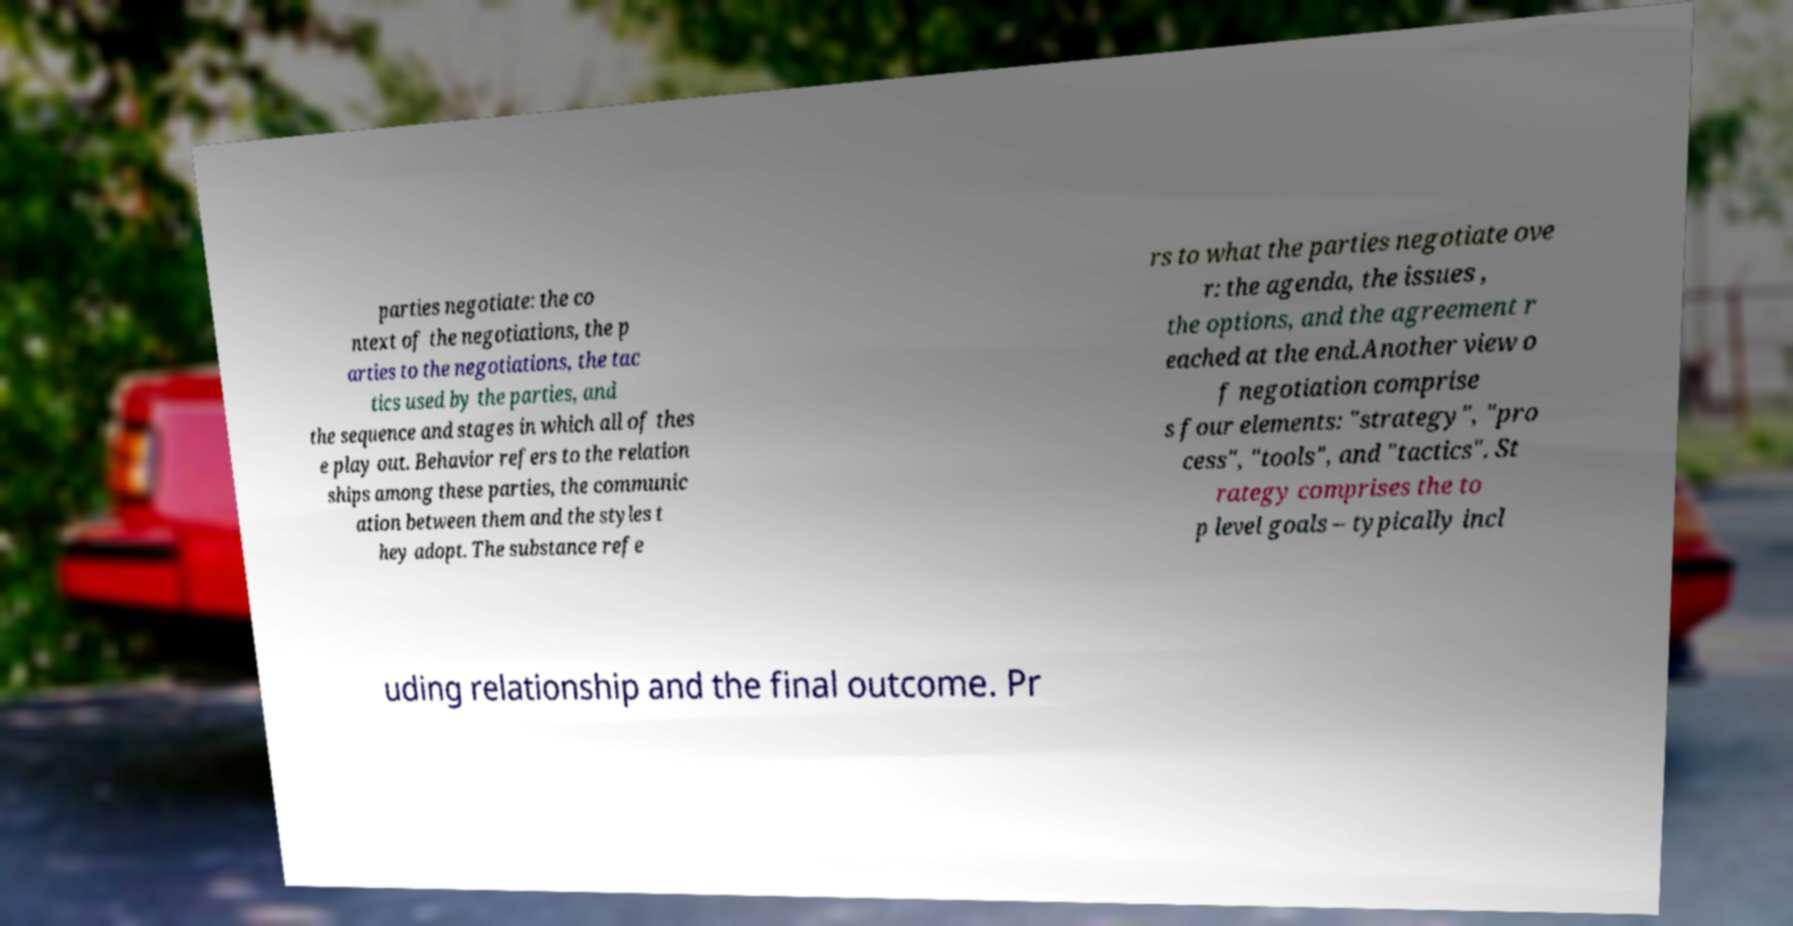I need the written content from this picture converted into text. Can you do that? parties negotiate: the co ntext of the negotiations, the p arties to the negotiations, the tac tics used by the parties, and the sequence and stages in which all of thes e play out. Behavior refers to the relation ships among these parties, the communic ation between them and the styles t hey adopt. The substance refe rs to what the parties negotiate ove r: the agenda, the issues , the options, and the agreement r eached at the end.Another view o f negotiation comprise s four elements: "strategy", "pro cess", "tools", and "tactics". St rategy comprises the to p level goals – typically incl uding relationship and the final outcome. Pr 